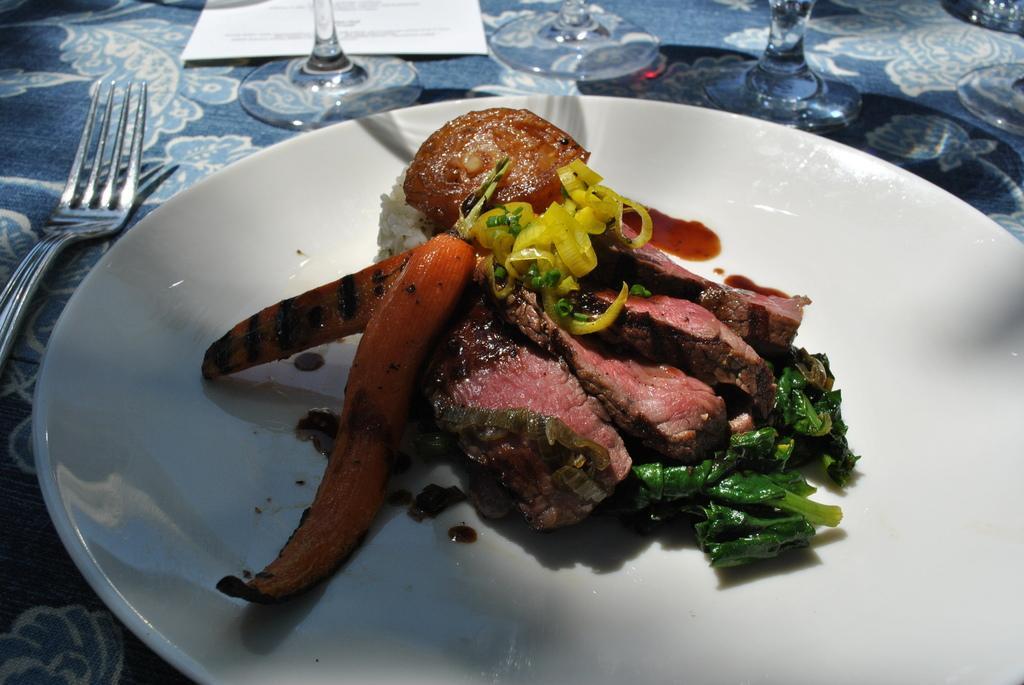In one or two sentences, can you explain what this image depicts? In the center of the image there is a table and we can see a plate containing food, a fork, paper and glasses placed on the table. 